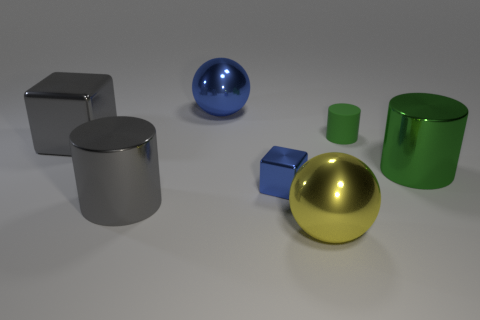Subtract all metallic cylinders. How many cylinders are left? 1 Subtract all gray cylinders. How many cylinders are left? 2 Subtract 2 cylinders. How many cylinders are left? 1 Subtract all cyan cubes. Subtract all yellow spheres. How many cubes are left? 2 Subtract all brown cylinders. How many brown blocks are left? 0 Add 1 gray metallic cylinders. How many gray metallic cylinders exist? 2 Add 1 large metal blocks. How many objects exist? 8 Subtract 0 yellow cylinders. How many objects are left? 7 Subtract all cylinders. How many objects are left? 4 Subtract all tiny blue shiny things. Subtract all red blocks. How many objects are left? 6 